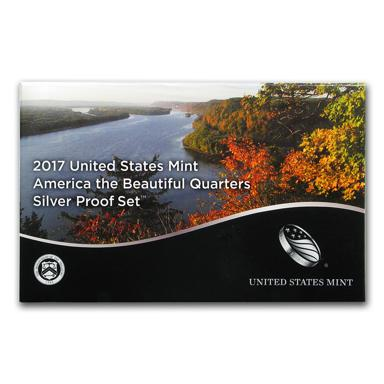What's the significance of the image on the packaging? The image on the packaging of the 2017 Silver Proof Set captures a stunning autumnal scene overlooking a serene river, which likely aims to evoke the natural beauty and tranquility of many of the sites commemorated by the quarters. This scenery enhances the thematic appeal of the quarters themselves, making the set not only a piece of numismatic interest but also a visually appealing keepsake. 